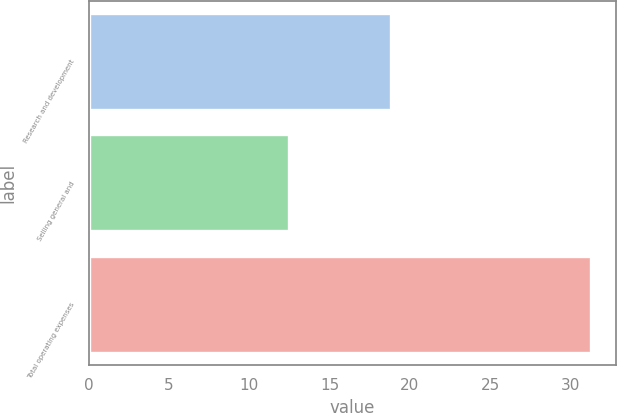<chart> <loc_0><loc_0><loc_500><loc_500><bar_chart><fcel>Research and development<fcel>Selling general and<fcel>Total operating expenses<nl><fcel>18.8<fcel>12.5<fcel>31.3<nl></chart> 